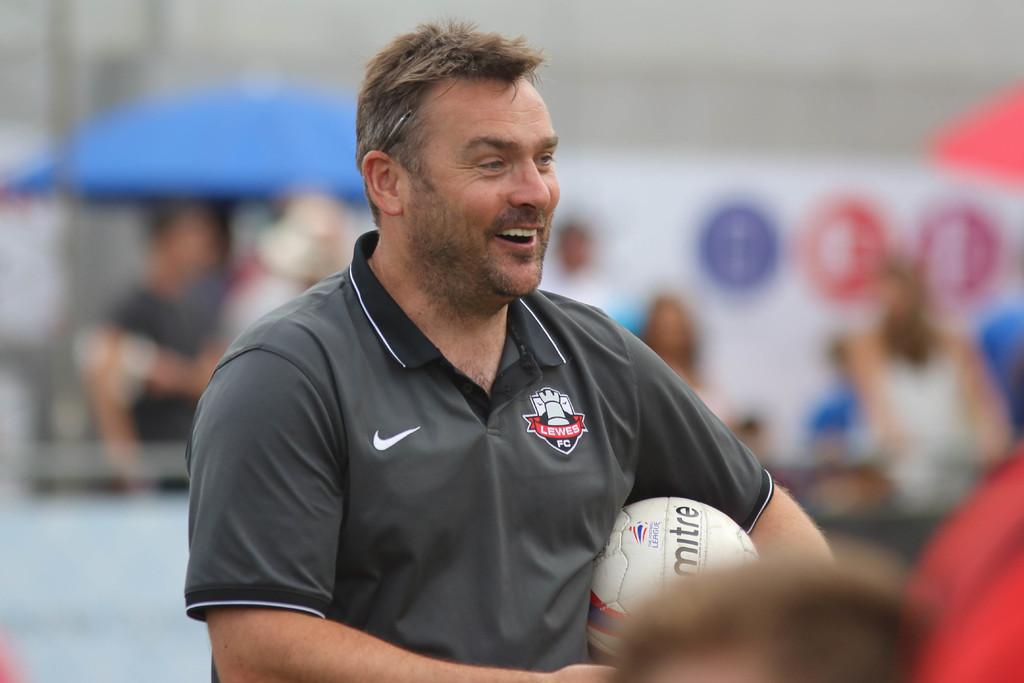Who is present in the image? There is a person in the image. What is the person wearing? The person is wearing a grey shirt. What is the person holding in their left hand? The person is holding a ball in their left hand. Can you describe the people behind the person? There is a group of people behind the person. What type of slave is depicted in the image? There is no slave depicted in the image; it features a person holding a ball. What answer is the person giving to the question in the image? There is no question or answer being given in the image; the person is simply holding a ball. 